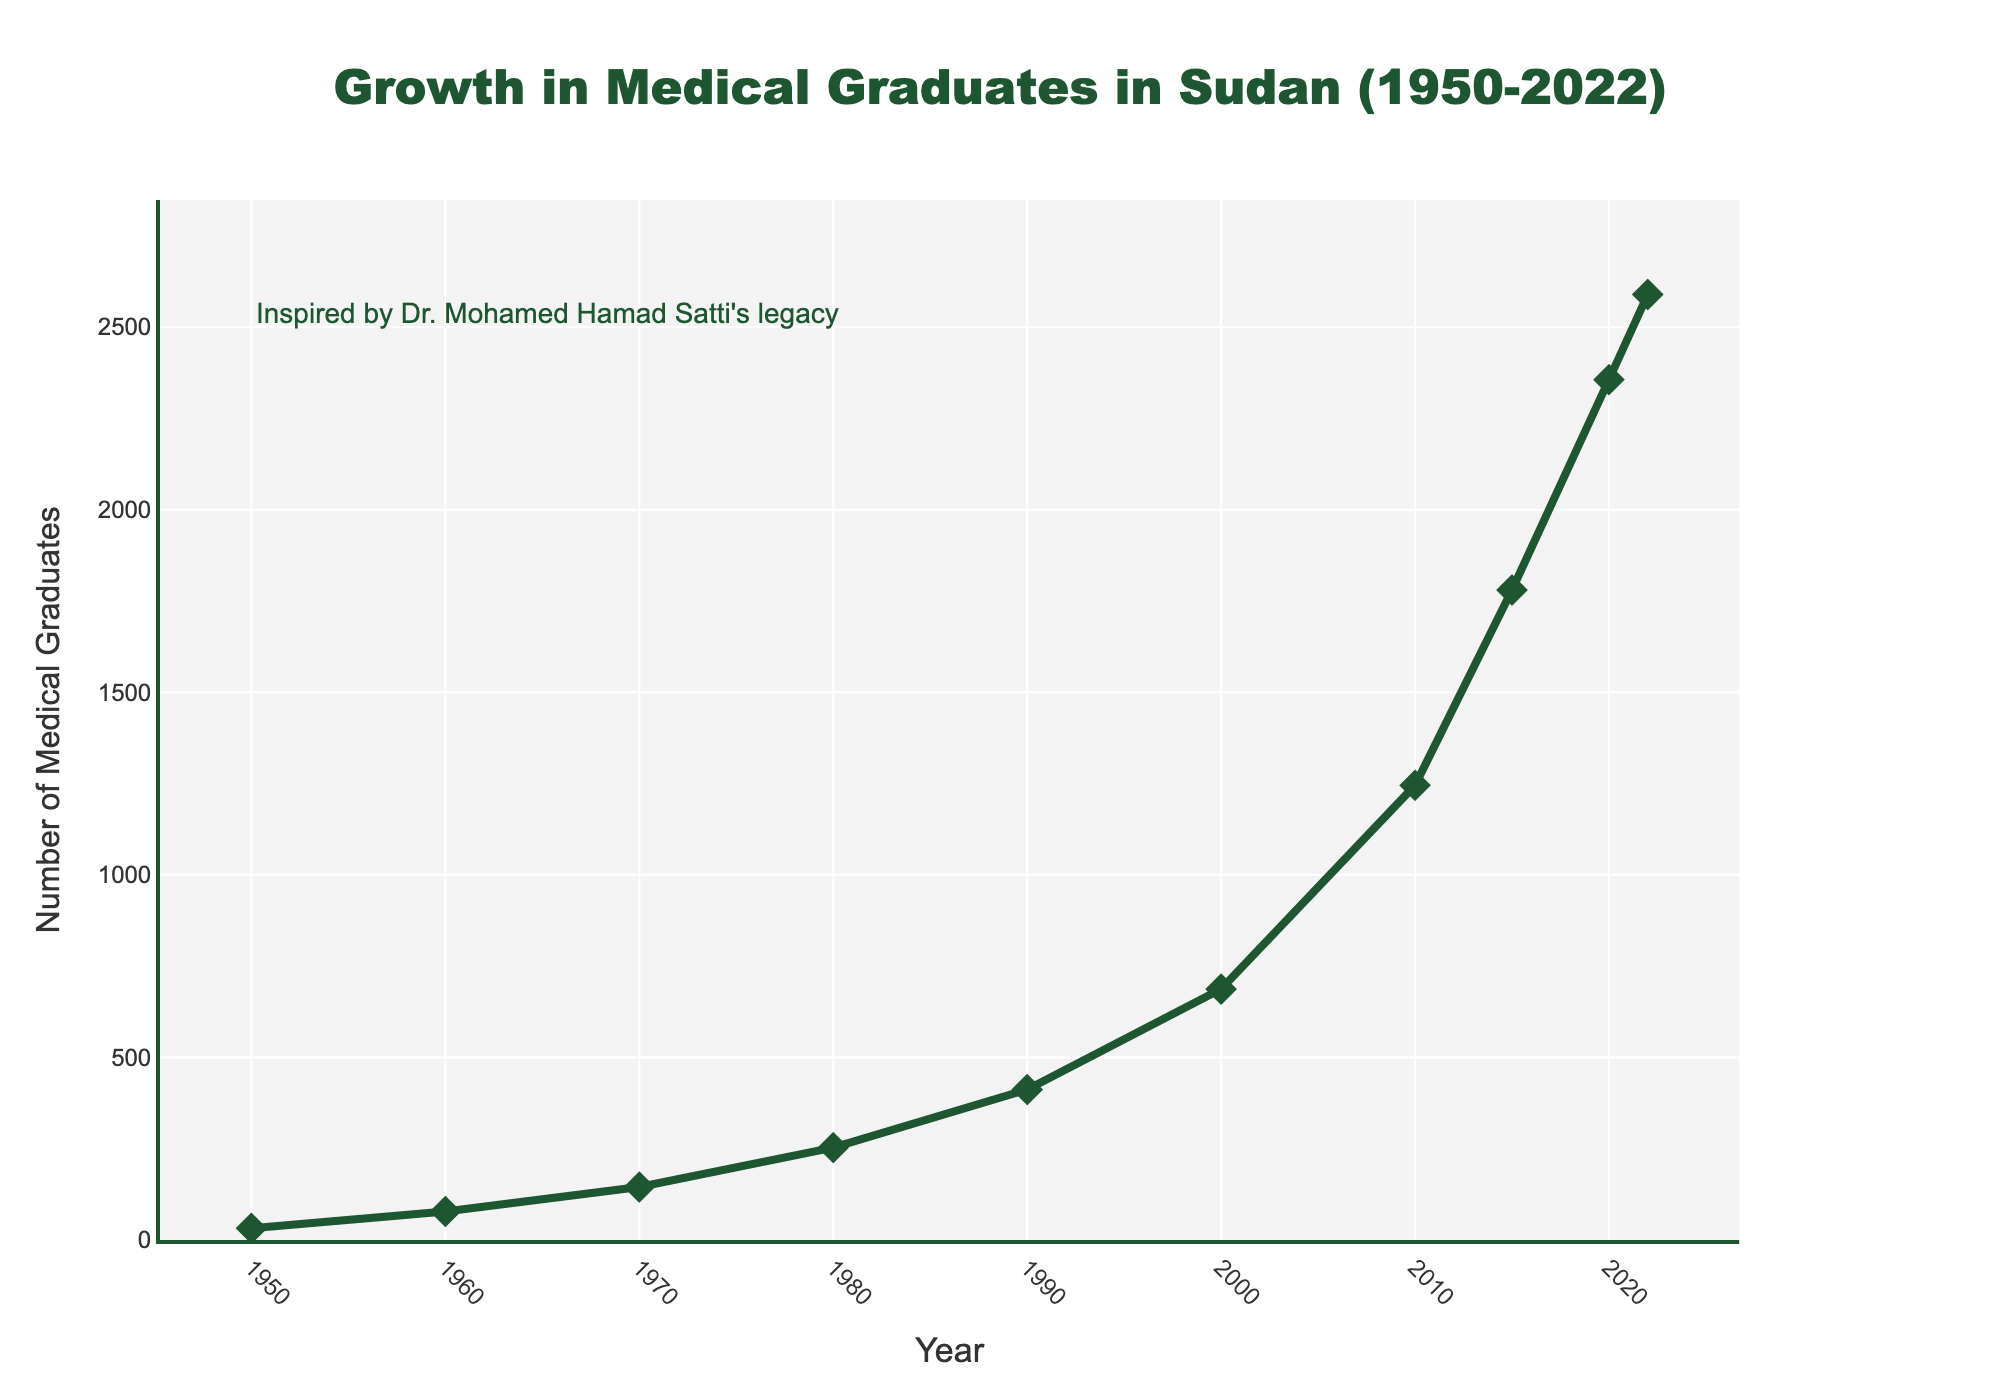What is the increase in the number of medical graduates from 1950 to 2022? In 1950, the number of medical graduates was 32. In 2022, it reached 2589. By subtracting the earlier value from the latter, 2589 - 32 = 2557.
Answer: 2557 In which decade did the number of medical graduates see the largest absolute increase? To find the largest absolute increase, compare the differences for each decade: 1960-1950: (78-32=46), 1970-1960: (145-78=67), 1980-1970: (253-145=108), 1990-1980: (412-253=159), 2000-1990: (687-412=275), 2010-2000: (1245-687=558), 2015-2010: (1780-1245=535), 2020-2015: (2356-1780=576), and 2022-2020: (2589-2356=233). The highest increase occurs between 2010 and 2015 with an increase of 558.
Answer: 2010 to 2015 What was the approximate average number of medical graduates per decade from 1950 to 2020? Compute the sum of graduates over seven decades from 1950 to 2010 (32+78+145+253+412+687+1245+1780+2356) = 6988, then divide by the number of decades (7). The average per decade is approximately 768.
Answer: 768 By how much did the number of medical graduates change from 1980 to 2000? First find the number of graduates in 1980 (253) and in 2000 (687). Then subtract them to get the change: 687 - 253 = 434.
Answer: 434 Which year had the most medical graduates, and what was the number? Look for the highest point on the figure, which is in 2022, with 2589 graduates.
Answer: 2022, 2589 What was the annual growth rate between 2015 and 2020? To find the annual growth rate, calculate: (Growth) / (Number of years). From 2015 (1780) to 2020 (2356) the increase is 2356 - 1780 = 576. Divide this increase by the number of years (2020-2015=5), 576 / 5 = 115.2 per year.
Answer: 115.2 per year How many more medical graduates were there in 2020 compared to 1990? In 1990, there were 412 graduates; in 2020, there were 2356. The difference is 2356 - 412 = 1944.
Answer: 1944 Compare the number of graduates in 1950 and 1970. How many times more graduates were there in 1970 compared to 1950? In 1950, there were 32 graduates, and in 1970, there were 145. To find out how many times more, divide the latter by the former: 145 / 32 ≈ 4.53.
Answer: 4.53 times Which period saw a visible stagnation in growth, if any? Compare the changes visually and observe that between 2020 and 2022, the increase was minimal compared to other periods: 2589-2356 = 233.
Answer: 2020 to 2022 Describe the trend in the number of medical graduates from 1950 to 2022. Visually, the line chart shows a steady increase in the number of graduates from 1950 to 1980, followed by a rapid increase from 1980 to 2020, with a slight slowing down between 2020 and 2022.
Answer: Steady growth from 1950 to 1980, rapid rise from 1980 to 2020, slight slowdown from 2020 to 2022 